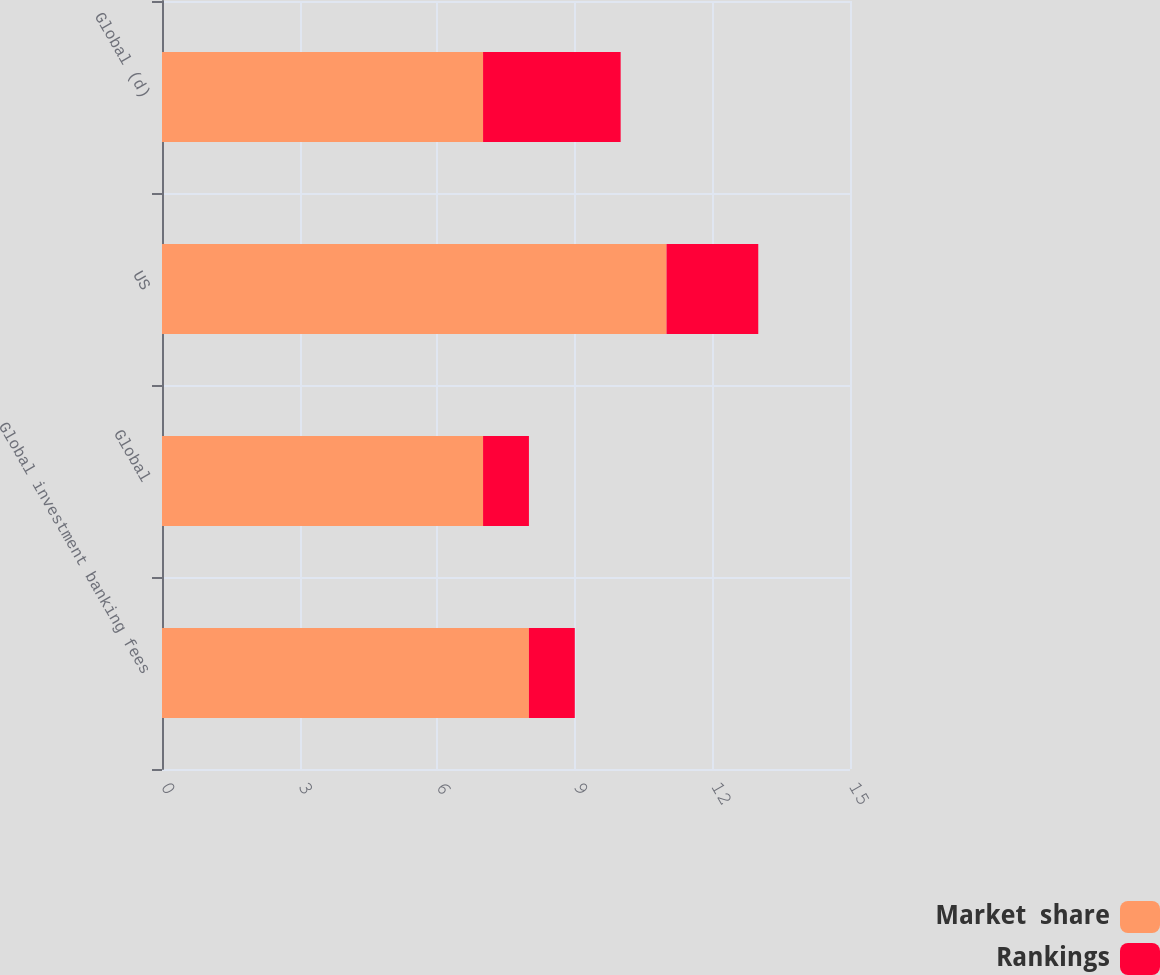<chart> <loc_0><loc_0><loc_500><loc_500><stacked_bar_chart><ecel><fcel>Global investment banking fees<fcel>Global<fcel>US<fcel>Global (d)<nl><fcel>Market  share<fcel>8<fcel>7<fcel>11<fcel>7<nl><fcel>Rankings<fcel>1<fcel>1<fcel>2<fcel>3<nl></chart> 